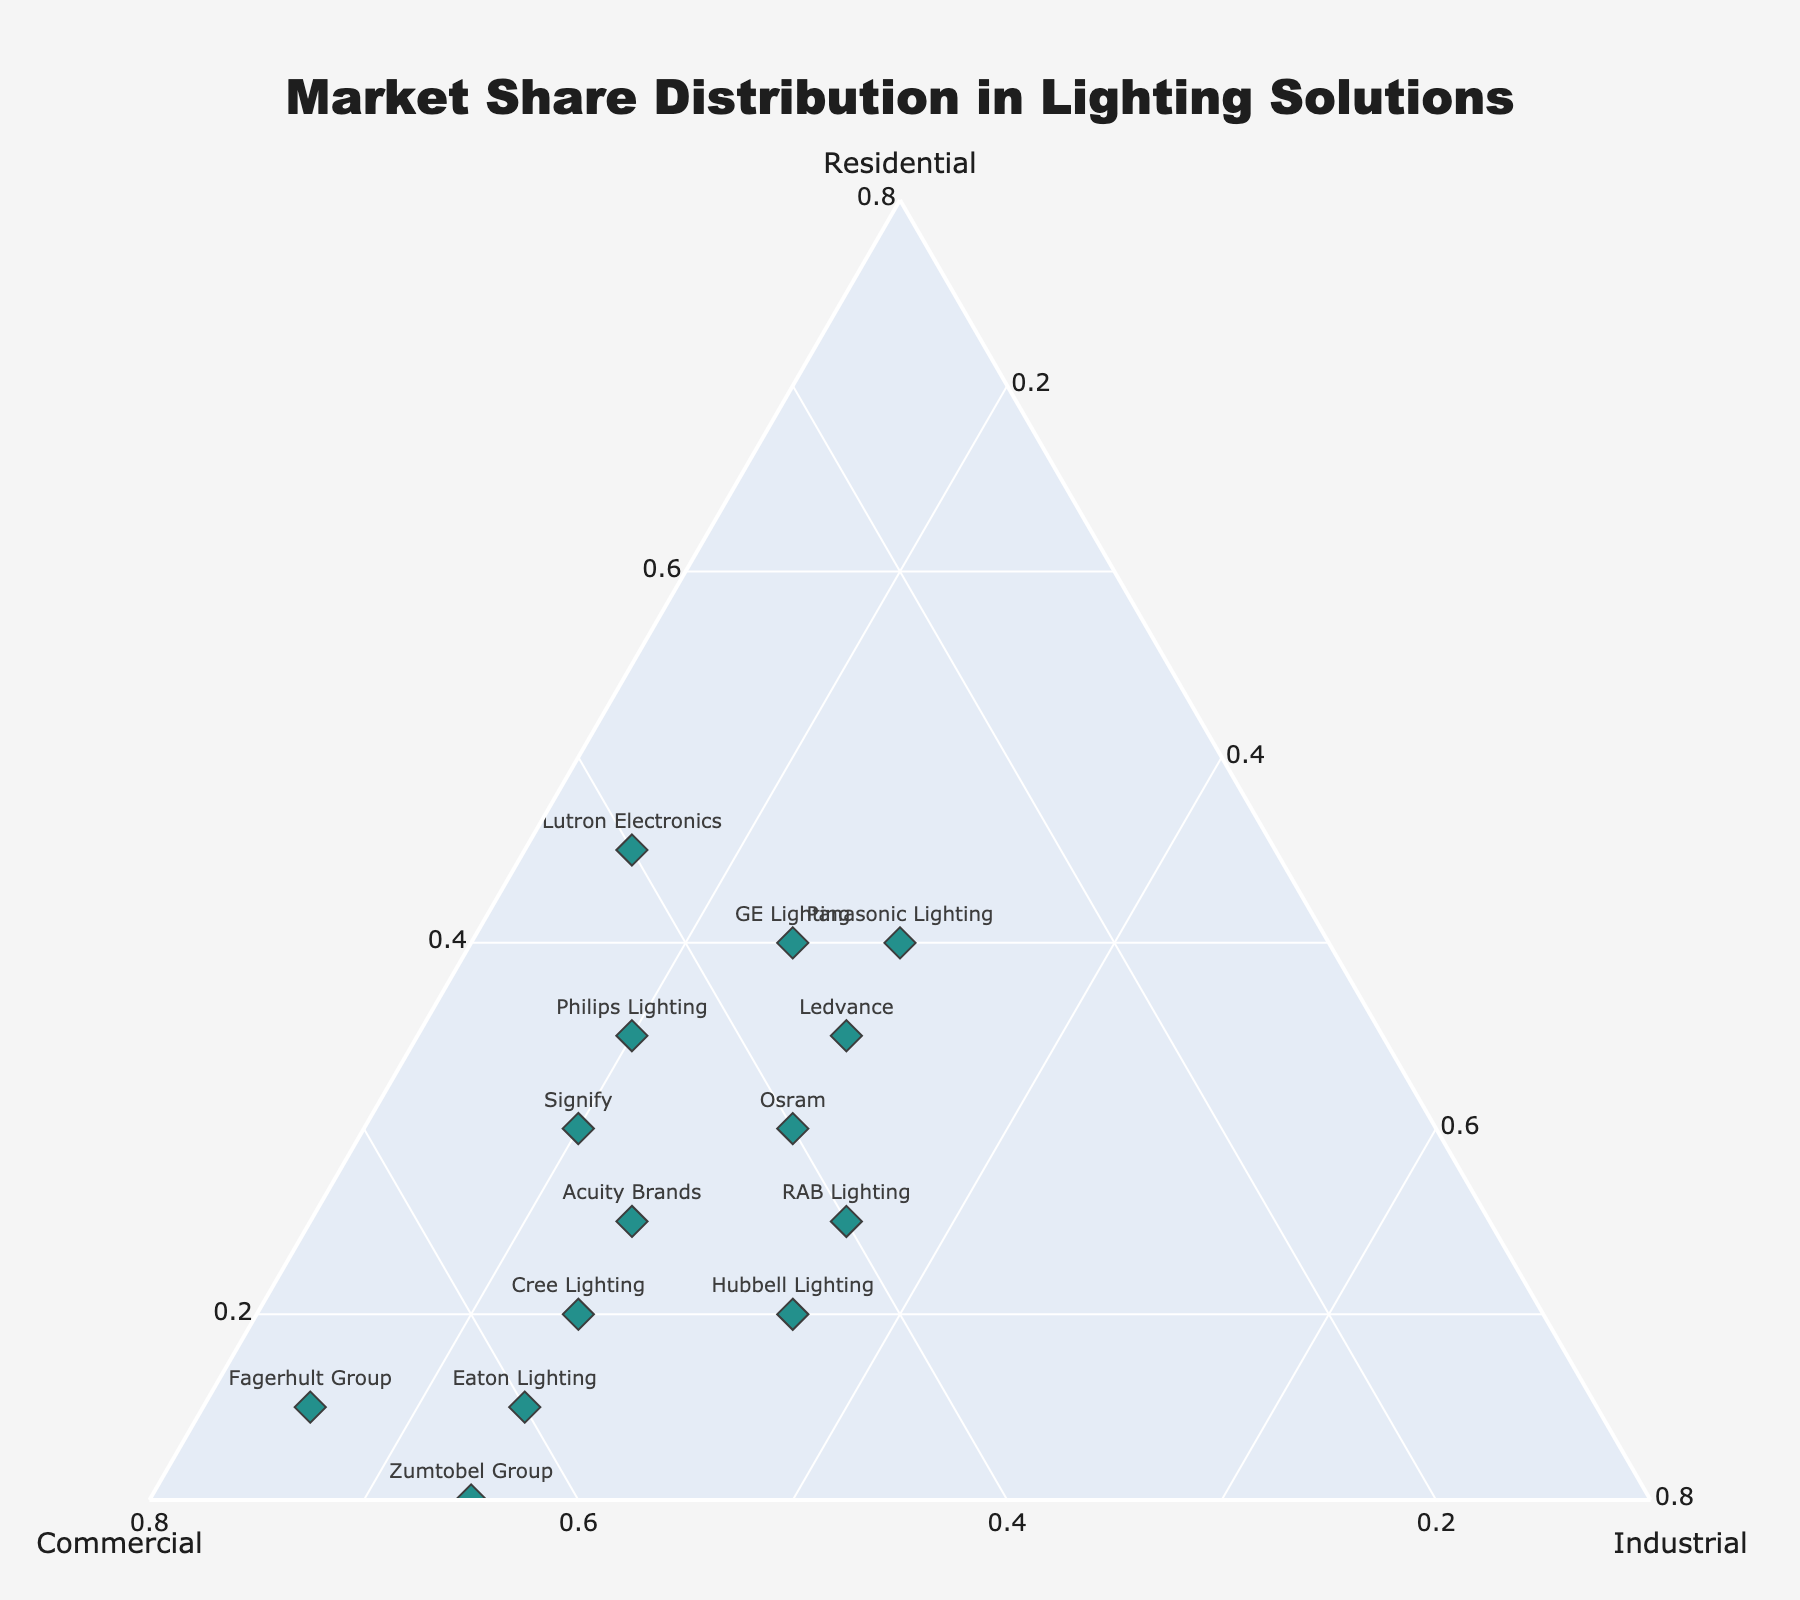What is the title of the figure? The title is placed at the top center of the figure and is noticeably larger and bolder. It states the purpose of the plot.
Answer: Market Share Distribution in Lighting Solutions How many companies are represented in the plot? Each marker represents a company, and by counting the total number of markers or labels, we can determine the number. The figure shows fifteen markers.
Answer: 15 Which company has the highest percentage in the Residential sector? By examining the markers near the 'Residential' axis, we identify the company with the highest value in this direction. Lutron Electronics is closest to this axis.
Answer: Lutron Electronics Which company has a balanced market share among Residential, Commercial, and Industrial sectors? Companies that are positioned near the center of the ternary plot have more balanced shares. By identifying such a marker, we find Osram.
Answer: Osram Compare the Residential market shares of Philips Lighting and Signify. Which one is greater? By checking the positions of both companies relative to the 'Residential' axis, Philips Lighting is closer to it than Signify.
Answer: Philips Lighting Which company has the highest percentage in the Commercial sector? By examining the markers closest to the 'Commercial' axis, Fagerhult Group is positioned nearest to it.
Answer: Fagerhult Group Which company has the largest Industrial market share? The position enarest to the 'Industrial' axis will help determine this. Dialight is the closest to this axis.
Answer: Dialight Calculate the average percentage of Residential market share for Philips Lighting and GE Lighting. Philips Lighting has 35% and GE Lighting has 40%. Calculating the average: (35 + 40) / 2 = 37.5
Answer: 37.5 Who has a higher combined market share in Residential and Commercial, Acuity Brands or Hubbell Lighting? Acuity Brands' combined percentage: 25 + 50 = 75%. Hubbell Lighting's combined percentage: 20 + 45 = 65%. Therefore, Acuity Brands has a higher combined share.
Answer: Acuity Brands Which company has the lowest Residential market share and what is it? By looking for the marker farthest from the 'Residential' axis, Dialight appears to be closest to the 'Industrial' axis. Its Residential percentage is 5%.
Answer: Dialight, 5% 